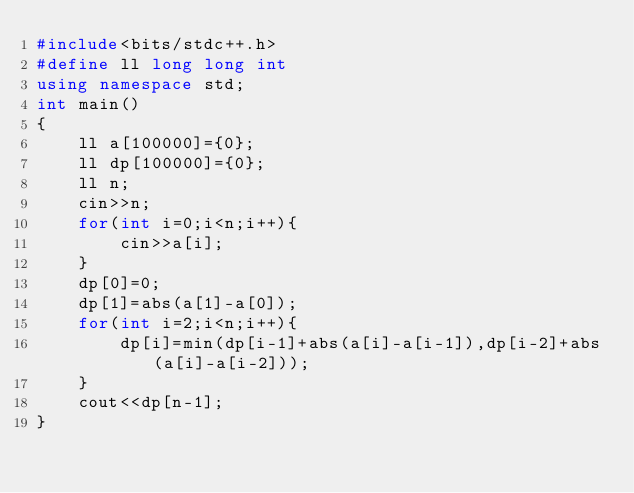<code> <loc_0><loc_0><loc_500><loc_500><_C++_>#include<bits/stdc++.h>
#define ll long long int
using namespace std;
int main()
{
    ll a[100000]={0};
    ll dp[100000]={0};
    ll n;
    cin>>n;
    for(int i=0;i<n;i++){
        cin>>a[i];
    }
    dp[0]=0;
    dp[1]=abs(a[1]-a[0]);
    for(int i=2;i<n;i++){
        dp[i]=min(dp[i-1]+abs(a[i]-a[i-1]),dp[i-2]+abs(a[i]-a[i-2]));
    }
    cout<<dp[n-1];
}</code> 